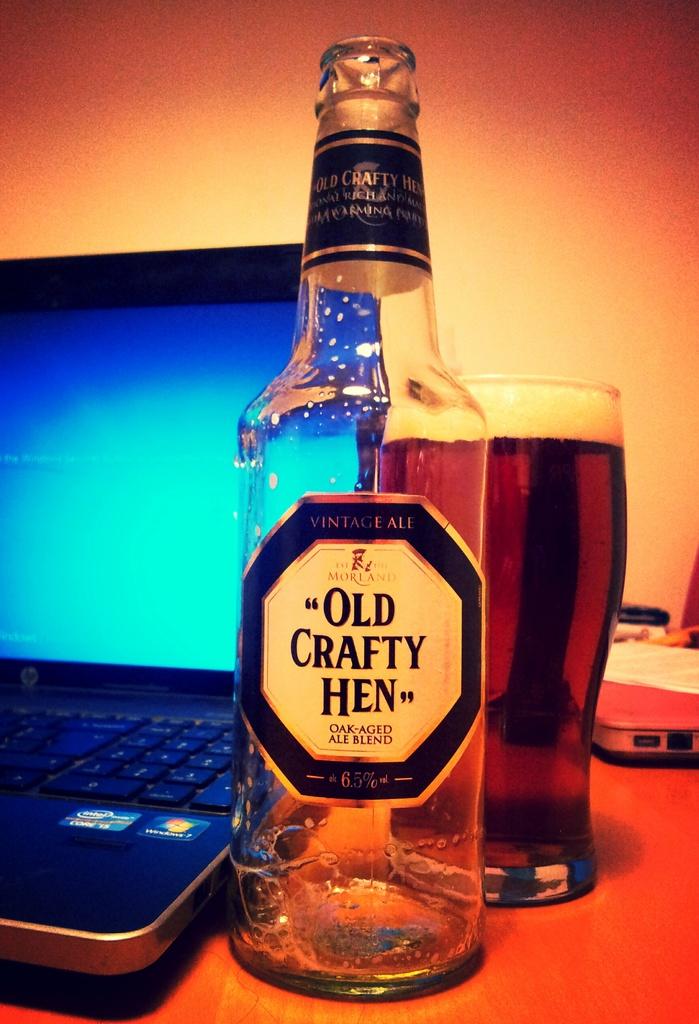What kind of ale is it?
Your answer should be very brief. Old crafty hen. 